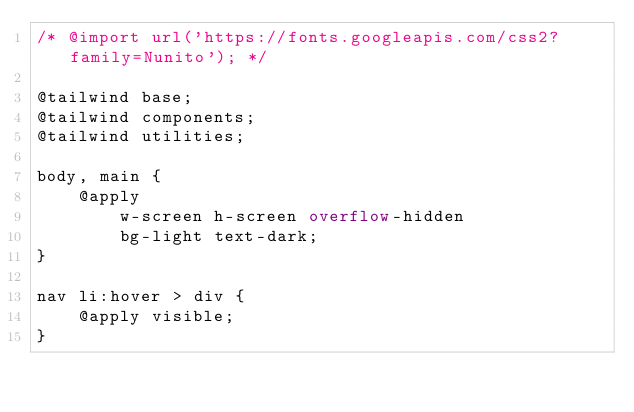Convert code to text. <code><loc_0><loc_0><loc_500><loc_500><_CSS_>/* @import url('https://fonts.googleapis.com/css2?family=Nunito'); */

@tailwind base;
@tailwind components;
@tailwind utilities;

body, main {
    @apply
        w-screen h-screen overflow-hidden
        bg-light text-dark;
}

nav li:hover > div {
    @apply visible;
}</code> 